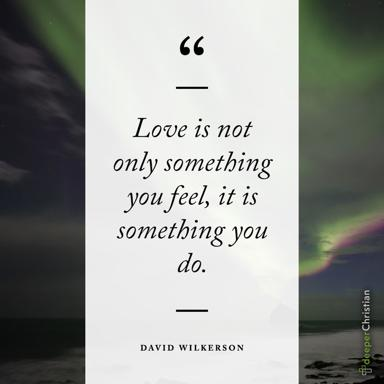What is the quote about love in the image? The quote in the image reads, "Love is not only something you feel, it is something you do." by David Wilkerson. Can you explain the quote by David Wilkerson? The quote by David Wilkerson suggests that love goes beyond just the emotions or feelings one experiences. It emphasizes that love also involves action and commitment. In other words, expressing love involves not just feeling affection towards someone but also demonstrating it through actions, such as care, support, and understanding. It underlines the idea that true love is shown in the way we treat others and engage with them in our daily lives. 